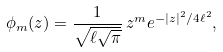<formula> <loc_0><loc_0><loc_500><loc_500>\phi _ { m } ( z ) = \frac { 1 } { \sqrt { \ell \sqrt { \pi } } } \, z ^ { m } e ^ { - | z | ^ { 2 } / 4 \ell ^ { 2 } } ,</formula> 